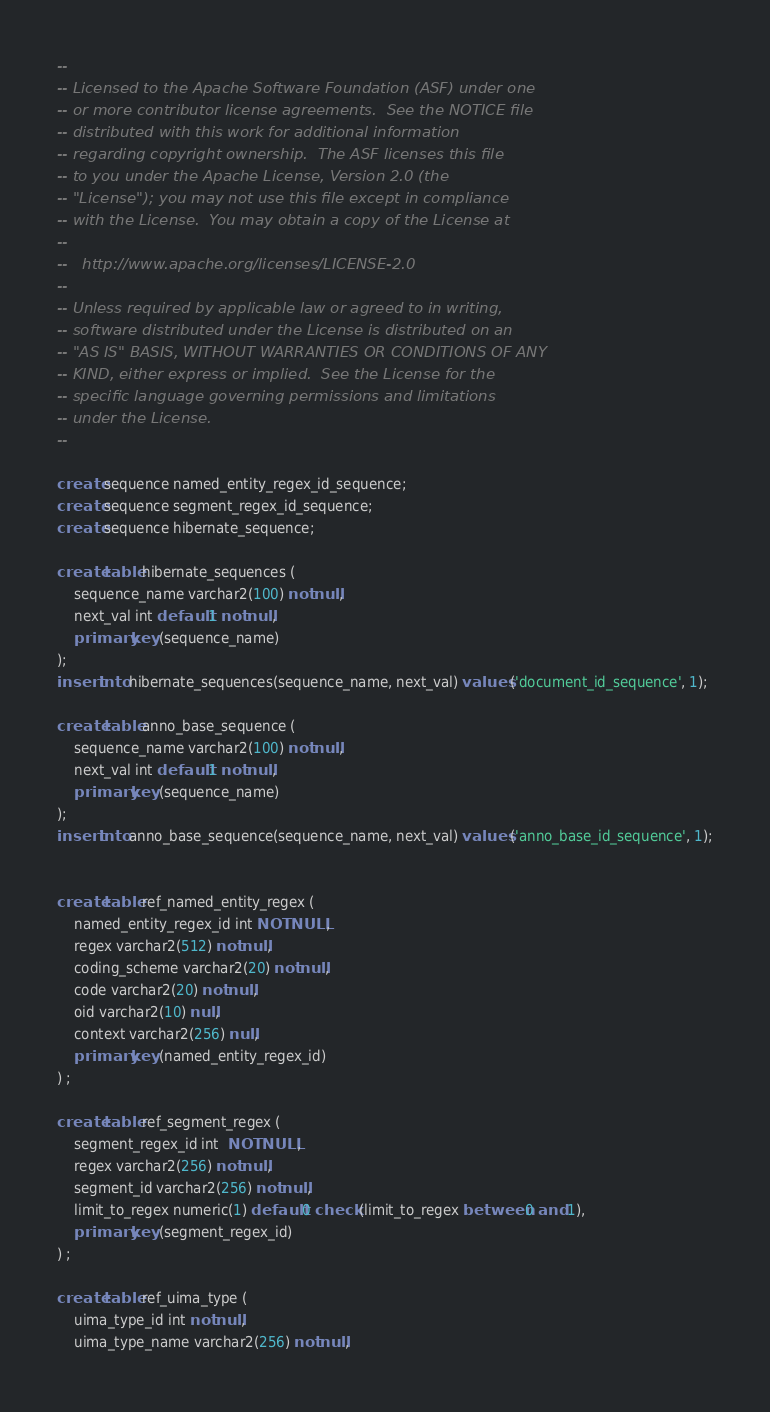<code> <loc_0><loc_0><loc_500><loc_500><_SQL_>--
-- Licensed to the Apache Software Foundation (ASF) under one
-- or more contributor license agreements.  See the NOTICE file
-- distributed with this work for additional information
-- regarding copyright ownership.  The ASF licenses this file
-- to you under the Apache License, Version 2.0 (the
-- "License"); you may not use this file except in compliance
-- with the License.  You may obtain a copy of the License at
--
--   http://www.apache.org/licenses/LICENSE-2.0
--
-- Unless required by applicable law or agreed to in writing,
-- software distributed under the License is distributed on an
-- "AS IS" BASIS, WITHOUT WARRANTIES OR CONDITIONS OF ANY
-- KIND, either express or implied.  See the License for the
-- specific language governing permissions and limitations
-- under the License.
--

create sequence named_entity_regex_id_sequence;
create sequence segment_regex_id_sequence;
create sequence hibernate_sequence;

create table hibernate_sequences (
	sequence_name varchar2(100) not null,
	next_val int default 1 not null,
	primary key (sequence_name)
);
insert into hibernate_sequences(sequence_name, next_val) values ('document_id_sequence', 1);

create table anno_base_sequence (
	sequence_name varchar2(100) not null,
	next_val int default 1 not null,
	primary key (sequence_name)
);
insert into anno_base_sequence(sequence_name, next_val) values ('anno_base_id_sequence', 1);


create table ref_named_entity_regex (
	named_entity_regex_id int NOT NULL,
	regex varchar2(512) not null,
	coding_scheme varchar2(20) not null,
	code varchar2(20) not null,
	oid varchar2(10) null,
	context varchar2(256) null,
	primary key (named_entity_regex_id)
) ;

create table ref_segment_regex (
	segment_regex_id int  NOT NULL,
	regex varchar2(256) not null,
	segment_id varchar2(256) not null,
	limit_to_regex numeric(1) default 0 check (limit_to_regex between 0 and 1),
	primary key (segment_regex_id)
) ;

create table ref_uima_type (
	uima_type_id int not null,
	uima_type_name varchar2(256) not null,</code> 